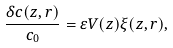<formula> <loc_0><loc_0><loc_500><loc_500>\frac { \delta c ( z , r ) } { c _ { 0 } } = \varepsilon V ( z ) \xi ( z , r ) ,</formula> 